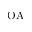<formula> <loc_0><loc_0><loc_500><loc_500>O A</formula> 